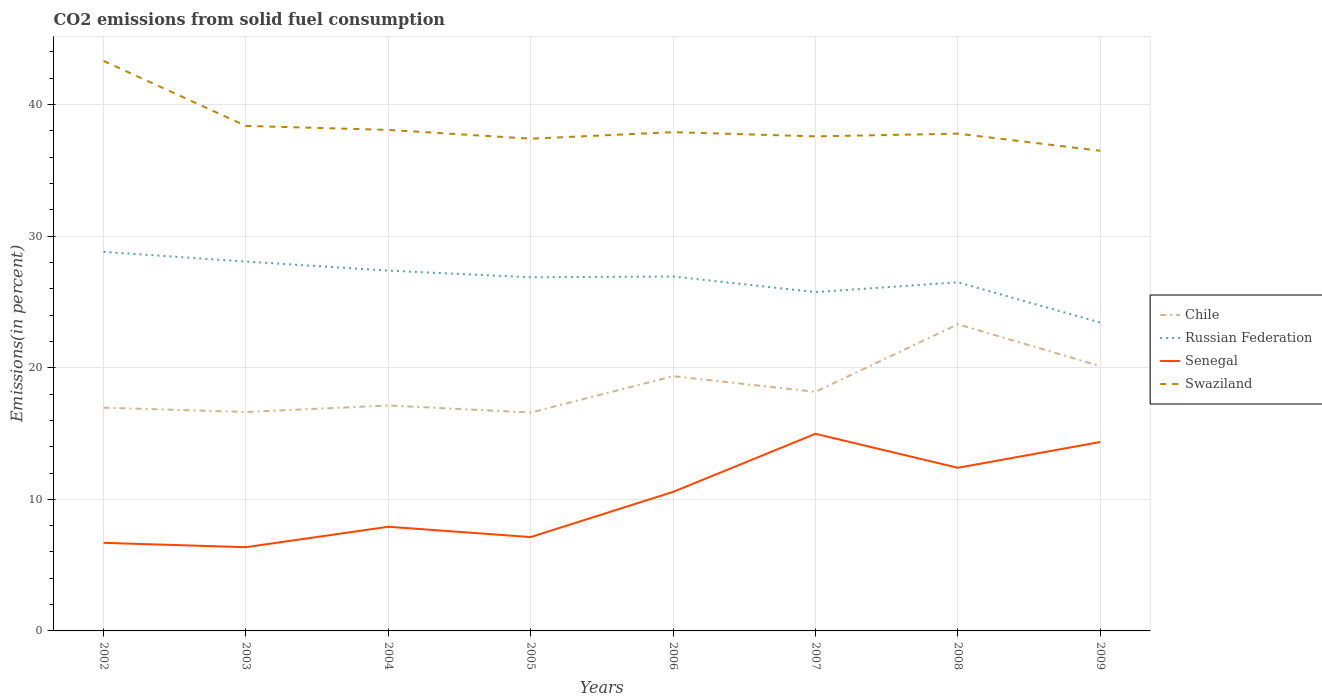How many different coloured lines are there?
Provide a succinct answer. 4. Is the number of lines equal to the number of legend labels?
Make the answer very short. Yes. Across all years, what is the maximum total CO2 emitted in Swaziland?
Offer a very short reply. 36.49. In which year was the total CO2 emitted in Chile maximum?
Your answer should be compact. 2005. What is the total total CO2 emitted in Swaziland in the graph?
Offer a terse response. 0.11. What is the difference between the highest and the second highest total CO2 emitted in Russian Federation?
Provide a succinct answer. 5.37. Is the total CO2 emitted in Chile strictly greater than the total CO2 emitted in Swaziland over the years?
Your response must be concise. Yes. How many lines are there?
Your response must be concise. 4. How many years are there in the graph?
Provide a succinct answer. 8. What is the difference between two consecutive major ticks on the Y-axis?
Your response must be concise. 10. Does the graph contain grids?
Offer a terse response. Yes. What is the title of the graph?
Provide a short and direct response. CO2 emissions from solid fuel consumption. Does "Russian Federation" appear as one of the legend labels in the graph?
Ensure brevity in your answer.  Yes. What is the label or title of the X-axis?
Offer a terse response. Years. What is the label or title of the Y-axis?
Give a very brief answer. Emissions(in percent). What is the Emissions(in percent) in Chile in 2002?
Provide a short and direct response. 16.96. What is the Emissions(in percent) of Russian Federation in 2002?
Offer a very short reply. 28.81. What is the Emissions(in percent) in Senegal in 2002?
Your response must be concise. 6.69. What is the Emissions(in percent) of Swaziland in 2002?
Make the answer very short. 43.32. What is the Emissions(in percent) of Chile in 2003?
Give a very brief answer. 16.64. What is the Emissions(in percent) in Russian Federation in 2003?
Offer a very short reply. 28.07. What is the Emissions(in percent) in Senegal in 2003?
Make the answer very short. 6.36. What is the Emissions(in percent) in Swaziland in 2003?
Give a very brief answer. 38.38. What is the Emissions(in percent) of Chile in 2004?
Your answer should be compact. 17.13. What is the Emissions(in percent) in Russian Federation in 2004?
Make the answer very short. 27.38. What is the Emissions(in percent) of Senegal in 2004?
Provide a short and direct response. 7.92. What is the Emissions(in percent) in Swaziland in 2004?
Offer a terse response. 38.08. What is the Emissions(in percent) of Chile in 2005?
Ensure brevity in your answer.  16.6. What is the Emissions(in percent) in Russian Federation in 2005?
Keep it short and to the point. 26.88. What is the Emissions(in percent) of Senegal in 2005?
Ensure brevity in your answer.  7.13. What is the Emissions(in percent) of Swaziland in 2005?
Make the answer very short. 37.41. What is the Emissions(in percent) of Chile in 2006?
Provide a short and direct response. 19.36. What is the Emissions(in percent) in Russian Federation in 2006?
Ensure brevity in your answer.  26.94. What is the Emissions(in percent) in Senegal in 2006?
Offer a terse response. 10.57. What is the Emissions(in percent) of Swaziland in 2006?
Your answer should be compact. 37.91. What is the Emissions(in percent) of Chile in 2007?
Your answer should be compact. 18.17. What is the Emissions(in percent) in Russian Federation in 2007?
Keep it short and to the point. 25.75. What is the Emissions(in percent) in Senegal in 2007?
Your answer should be compact. 14.98. What is the Emissions(in percent) in Swaziland in 2007?
Make the answer very short. 37.59. What is the Emissions(in percent) of Chile in 2008?
Make the answer very short. 23.31. What is the Emissions(in percent) in Russian Federation in 2008?
Ensure brevity in your answer.  26.5. What is the Emissions(in percent) of Senegal in 2008?
Your answer should be very brief. 12.4. What is the Emissions(in percent) in Swaziland in 2008?
Your answer should be compact. 37.79. What is the Emissions(in percent) of Chile in 2009?
Your answer should be compact. 20.12. What is the Emissions(in percent) in Russian Federation in 2009?
Offer a very short reply. 23.43. What is the Emissions(in percent) of Senegal in 2009?
Your response must be concise. 14.36. What is the Emissions(in percent) in Swaziland in 2009?
Provide a succinct answer. 36.49. Across all years, what is the maximum Emissions(in percent) of Chile?
Give a very brief answer. 23.31. Across all years, what is the maximum Emissions(in percent) in Russian Federation?
Offer a terse response. 28.81. Across all years, what is the maximum Emissions(in percent) of Senegal?
Your response must be concise. 14.98. Across all years, what is the maximum Emissions(in percent) in Swaziland?
Your answer should be compact. 43.32. Across all years, what is the minimum Emissions(in percent) of Chile?
Keep it short and to the point. 16.6. Across all years, what is the minimum Emissions(in percent) in Russian Federation?
Your answer should be very brief. 23.43. Across all years, what is the minimum Emissions(in percent) of Senegal?
Ensure brevity in your answer.  6.36. Across all years, what is the minimum Emissions(in percent) of Swaziland?
Offer a very short reply. 36.49. What is the total Emissions(in percent) in Chile in the graph?
Make the answer very short. 148.3. What is the total Emissions(in percent) in Russian Federation in the graph?
Offer a very short reply. 213.75. What is the total Emissions(in percent) of Senegal in the graph?
Your answer should be very brief. 80.41. What is the total Emissions(in percent) of Swaziland in the graph?
Your answer should be very brief. 306.97. What is the difference between the Emissions(in percent) of Chile in 2002 and that in 2003?
Your answer should be very brief. 0.33. What is the difference between the Emissions(in percent) in Russian Federation in 2002 and that in 2003?
Give a very brief answer. 0.74. What is the difference between the Emissions(in percent) in Senegal in 2002 and that in 2003?
Provide a succinct answer. 0.33. What is the difference between the Emissions(in percent) of Swaziland in 2002 and that in 2003?
Offer a terse response. 4.94. What is the difference between the Emissions(in percent) in Chile in 2002 and that in 2004?
Give a very brief answer. -0.17. What is the difference between the Emissions(in percent) in Russian Federation in 2002 and that in 2004?
Offer a very short reply. 1.43. What is the difference between the Emissions(in percent) of Senegal in 2002 and that in 2004?
Make the answer very short. -1.22. What is the difference between the Emissions(in percent) in Swaziland in 2002 and that in 2004?
Ensure brevity in your answer.  5.24. What is the difference between the Emissions(in percent) of Chile in 2002 and that in 2005?
Make the answer very short. 0.37. What is the difference between the Emissions(in percent) of Russian Federation in 2002 and that in 2005?
Offer a very short reply. 1.93. What is the difference between the Emissions(in percent) in Senegal in 2002 and that in 2005?
Your response must be concise. -0.44. What is the difference between the Emissions(in percent) of Swaziland in 2002 and that in 2005?
Your answer should be compact. 5.91. What is the difference between the Emissions(in percent) in Chile in 2002 and that in 2006?
Offer a very short reply. -2.4. What is the difference between the Emissions(in percent) in Russian Federation in 2002 and that in 2006?
Make the answer very short. 1.87. What is the difference between the Emissions(in percent) of Senegal in 2002 and that in 2006?
Offer a terse response. -3.87. What is the difference between the Emissions(in percent) in Swaziland in 2002 and that in 2006?
Ensure brevity in your answer.  5.42. What is the difference between the Emissions(in percent) of Chile in 2002 and that in 2007?
Your response must be concise. -1.21. What is the difference between the Emissions(in percent) of Russian Federation in 2002 and that in 2007?
Give a very brief answer. 3.06. What is the difference between the Emissions(in percent) in Senegal in 2002 and that in 2007?
Offer a very short reply. -8.29. What is the difference between the Emissions(in percent) of Swaziland in 2002 and that in 2007?
Provide a succinct answer. 5.74. What is the difference between the Emissions(in percent) of Chile in 2002 and that in 2008?
Offer a terse response. -6.34. What is the difference between the Emissions(in percent) in Russian Federation in 2002 and that in 2008?
Give a very brief answer. 2.31. What is the difference between the Emissions(in percent) of Senegal in 2002 and that in 2008?
Your answer should be very brief. -5.71. What is the difference between the Emissions(in percent) of Swaziland in 2002 and that in 2008?
Your answer should be compact. 5.53. What is the difference between the Emissions(in percent) in Chile in 2002 and that in 2009?
Give a very brief answer. -3.16. What is the difference between the Emissions(in percent) of Russian Federation in 2002 and that in 2009?
Offer a terse response. 5.38. What is the difference between the Emissions(in percent) of Senegal in 2002 and that in 2009?
Your answer should be compact. -7.66. What is the difference between the Emissions(in percent) in Swaziland in 2002 and that in 2009?
Provide a succinct answer. 6.83. What is the difference between the Emissions(in percent) in Chile in 2003 and that in 2004?
Your answer should be very brief. -0.49. What is the difference between the Emissions(in percent) in Russian Federation in 2003 and that in 2004?
Provide a succinct answer. 0.69. What is the difference between the Emissions(in percent) in Senegal in 2003 and that in 2004?
Provide a succinct answer. -1.55. What is the difference between the Emissions(in percent) in Swaziland in 2003 and that in 2004?
Your answer should be very brief. 0.3. What is the difference between the Emissions(in percent) of Chile in 2003 and that in 2005?
Offer a terse response. 0.04. What is the difference between the Emissions(in percent) of Russian Federation in 2003 and that in 2005?
Give a very brief answer. 1.19. What is the difference between the Emissions(in percent) of Senegal in 2003 and that in 2005?
Your response must be concise. -0.77. What is the difference between the Emissions(in percent) of Swaziland in 2003 and that in 2005?
Your answer should be very brief. 0.97. What is the difference between the Emissions(in percent) in Chile in 2003 and that in 2006?
Make the answer very short. -2.72. What is the difference between the Emissions(in percent) in Russian Federation in 2003 and that in 2006?
Your answer should be compact. 1.13. What is the difference between the Emissions(in percent) of Senegal in 2003 and that in 2006?
Ensure brevity in your answer.  -4.2. What is the difference between the Emissions(in percent) of Swaziland in 2003 and that in 2006?
Give a very brief answer. 0.47. What is the difference between the Emissions(in percent) in Chile in 2003 and that in 2007?
Provide a short and direct response. -1.53. What is the difference between the Emissions(in percent) in Russian Federation in 2003 and that in 2007?
Ensure brevity in your answer.  2.32. What is the difference between the Emissions(in percent) of Senegal in 2003 and that in 2007?
Your answer should be compact. -8.62. What is the difference between the Emissions(in percent) of Swaziland in 2003 and that in 2007?
Make the answer very short. 0.79. What is the difference between the Emissions(in percent) in Chile in 2003 and that in 2008?
Ensure brevity in your answer.  -6.67. What is the difference between the Emissions(in percent) of Russian Federation in 2003 and that in 2008?
Provide a succinct answer. 1.57. What is the difference between the Emissions(in percent) in Senegal in 2003 and that in 2008?
Keep it short and to the point. -6.03. What is the difference between the Emissions(in percent) in Swaziland in 2003 and that in 2008?
Your answer should be compact. 0.59. What is the difference between the Emissions(in percent) in Chile in 2003 and that in 2009?
Your response must be concise. -3.48. What is the difference between the Emissions(in percent) in Russian Federation in 2003 and that in 2009?
Offer a very short reply. 4.64. What is the difference between the Emissions(in percent) of Senegal in 2003 and that in 2009?
Your response must be concise. -7.99. What is the difference between the Emissions(in percent) of Swaziland in 2003 and that in 2009?
Keep it short and to the point. 1.89. What is the difference between the Emissions(in percent) in Chile in 2004 and that in 2005?
Make the answer very short. 0.54. What is the difference between the Emissions(in percent) of Russian Federation in 2004 and that in 2005?
Your answer should be very brief. 0.51. What is the difference between the Emissions(in percent) in Senegal in 2004 and that in 2005?
Provide a succinct answer. 0.78. What is the difference between the Emissions(in percent) in Swaziland in 2004 and that in 2005?
Your answer should be compact. 0.67. What is the difference between the Emissions(in percent) of Chile in 2004 and that in 2006?
Offer a terse response. -2.23. What is the difference between the Emissions(in percent) of Russian Federation in 2004 and that in 2006?
Your answer should be very brief. 0.45. What is the difference between the Emissions(in percent) in Senegal in 2004 and that in 2006?
Ensure brevity in your answer.  -2.65. What is the difference between the Emissions(in percent) of Swaziland in 2004 and that in 2006?
Your response must be concise. 0.17. What is the difference between the Emissions(in percent) of Chile in 2004 and that in 2007?
Offer a terse response. -1.04. What is the difference between the Emissions(in percent) in Russian Federation in 2004 and that in 2007?
Give a very brief answer. 1.63. What is the difference between the Emissions(in percent) of Senegal in 2004 and that in 2007?
Provide a succinct answer. -7.07. What is the difference between the Emissions(in percent) in Swaziland in 2004 and that in 2007?
Provide a short and direct response. 0.49. What is the difference between the Emissions(in percent) in Chile in 2004 and that in 2008?
Your answer should be very brief. -6.17. What is the difference between the Emissions(in percent) in Russian Federation in 2004 and that in 2008?
Your answer should be very brief. 0.89. What is the difference between the Emissions(in percent) in Senegal in 2004 and that in 2008?
Provide a succinct answer. -4.48. What is the difference between the Emissions(in percent) in Swaziland in 2004 and that in 2008?
Your answer should be very brief. 0.29. What is the difference between the Emissions(in percent) of Chile in 2004 and that in 2009?
Provide a short and direct response. -2.99. What is the difference between the Emissions(in percent) of Russian Federation in 2004 and that in 2009?
Ensure brevity in your answer.  3.95. What is the difference between the Emissions(in percent) of Senegal in 2004 and that in 2009?
Ensure brevity in your answer.  -6.44. What is the difference between the Emissions(in percent) in Swaziland in 2004 and that in 2009?
Keep it short and to the point. 1.59. What is the difference between the Emissions(in percent) in Chile in 2005 and that in 2006?
Make the answer very short. -2.76. What is the difference between the Emissions(in percent) in Russian Federation in 2005 and that in 2006?
Give a very brief answer. -0.06. What is the difference between the Emissions(in percent) of Senegal in 2005 and that in 2006?
Offer a very short reply. -3.43. What is the difference between the Emissions(in percent) of Swaziland in 2005 and that in 2006?
Your answer should be compact. -0.5. What is the difference between the Emissions(in percent) in Chile in 2005 and that in 2007?
Keep it short and to the point. -1.57. What is the difference between the Emissions(in percent) of Russian Federation in 2005 and that in 2007?
Offer a terse response. 1.12. What is the difference between the Emissions(in percent) of Senegal in 2005 and that in 2007?
Keep it short and to the point. -7.85. What is the difference between the Emissions(in percent) in Swaziland in 2005 and that in 2007?
Provide a succinct answer. -0.18. What is the difference between the Emissions(in percent) of Chile in 2005 and that in 2008?
Offer a very short reply. -6.71. What is the difference between the Emissions(in percent) of Russian Federation in 2005 and that in 2008?
Provide a succinct answer. 0.38. What is the difference between the Emissions(in percent) of Senegal in 2005 and that in 2008?
Keep it short and to the point. -5.26. What is the difference between the Emissions(in percent) of Swaziland in 2005 and that in 2008?
Provide a short and direct response. -0.38. What is the difference between the Emissions(in percent) in Chile in 2005 and that in 2009?
Your response must be concise. -3.53. What is the difference between the Emissions(in percent) of Russian Federation in 2005 and that in 2009?
Offer a very short reply. 3.44. What is the difference between the Emissions(in percent) in Senegal in 2005 and that in 2009?
Your answer should be very brief. -7.22. What is the difference between the Emissions(in percent) in Swaziland in 2005 and that in 2009?
Offer a very short reply. 0.92. What is the difference between the Emissions(in percent) of Chile in 2006 and that in 2007?
Your response must be concise. 1.19. What is the difference between the Emissions(in percent) in Russian Federation in 2006 and that in 2007?
Provide a succinct answer. 1.19. What is the difference between the Emissions(in percent) in Senegal in 2006 and that in 2007?
Provide a succinct answer. -4.42. What is the difference between the Emissions(in percent) in Swaziland in 2006 and that in 2007?
Ensure brevity in your answer.  0.32. What is the difference between the Emissions(in percent) of Chile in 2006 and that in 2008?
Your response must be concise. -3.95. What is the difference between the Emissions(in percent) of Russian Federation in 2006 and that in 2008?
Offer a terse response. 0.44. What is the difference between the Emissions(in percent) in Senegal in 2006 and that in 2008?
Your answer should be very brief. -1.83. What is the difference between the Emissions(in percent) in Swaziland in 2006 and that in 2008?
Ensure brevity in your answer.  0.11. What is the difference between the Emissions(in percent) in Chile in 2006 and that in 2009?
Make the answer very short. -0.76. What is the difference between the Emissions(in percent) of Russian Federation in 2006 and that in 2009?
Your answer should be very brief. 3.5. What is the difference between the Emissions(in percent) of Senegal in 2006 and that in 2009?
Provide a short and direct response. -3.79. What is the difference between the Emissions(in percent) of Swaziland in 2006 and that in 2009?
Ensure brevity in your answer.  1.41. What is the difference between the Emissions(in percent) in Chile in 2007 and that in 2008?
Offer a terse response. -5.14. What is the difference between the Emissions(in percent) of Russian Federation in 2007 and that in 2008?
Your answer should be very brief. -0.74. What is the difference between the Emissions(in percent) in Senegal in 2007 and that in 2008?
Make the answer very short. 2.58. What is the difference between the Emissions(in percent) in Swaziland in 2007 and that in 2008?
Your response must be concise. -0.21. What is the difference between the Emissions(in percent) in Chile in 2007 and that in 2009?
Your answer should be very brief. -1.95. What is the difference between the Emissions(in percent) in Russian Federation in 2007 and that in 2009?
Make the answer very short. 2.32. What is the difference between the Emissions(in percent) of Senegal in 2007 and that in 2009?
Your answer should be compact. 0.63. What is the difference between the Emissions(in percent) in Swaziland in 2007 and that in 2009?
Ensure brevity in your answer.  1.09. What is the difference between the Emissions(in percent) of Chile in 2008 and that in 2009?
Your answer should be compact. 3.19. What is the difference between the Emissions(in percent) of Russian Federation in 2008 and that in 2009?
Give a very brief answer. 3.06. What is the difference between the Emissions(in percent) of Senegal in 2008 and that in 2009?
Give a very brief answer. -1.96. What is the difference between the Emissions(in percent) in Swaziland in 2008 and that in 2009?
Keep it short and to the point. 1.3. What is the difference between the Emissions(in percent) in Chile in 2002 and the Emissions(in percent) in Russian Federation in 2003?
Make the answer very short. -11.11. What is the difference between the Emissions(in percent) in Chile in 2002 and the Emissions(in percent) in Senegal in 2003?
Provide a short and direct response. 10.6. What is the difference between the Emissions(in percent) of Chile in 2002 and the Emissions(in percent) of Swaziland in 2003?
Your answer should be very brief. -21.42. What is the difference between the Emissions(in percent) in Russian Federation in 2002 and the Emissions(in percent) in Senegal in 2003?
Offer a very short reply. 22.44. What is the difference between the Emissions(in percent) of Russian Federation in 2002 and the Emissions(in percent) of Swaziland in 2003?
Your response must be concise. -9.57. What is the difference between the Emissions(in percent) of Senegal in 2002 and the Emissions(in percent) of Swaziland in 2003?
Your response must be concise. -31.69. What is the difference between the Emissions(in percent) of Chile in 2002 and the Emissions(in percent) of Russian Federation in 2004?
Offer a terse response. -10.42. What is the difference between the Emissions(in percent) in Chile in 2002 and the Emissions(in percent) in Senegal in 2004?
Ensure brevity in your answer.  9.05. What is the difference between the Emissions(in percent) of Chile in 2002 and the Emissions(in percent) of Swaziland in 2004?
Offer a very short reply. -21.11. What is the difference between the Emissions(in percent) in Russian Federation in 2002 and the Emissions(in percent) in Senegal in 2004?
Offer a terse response. 20.89. What is the difference between the Emissions(in percent) of Russian Federation in 2002 and the Emissions(in percent) of Swaziland in 2004?
Your answer should be compact. -9.27. What is the difference between the Emissions(in percent) of Senegal in 2002 and the Emissions(in percent) of Swaziland in 2004?
Ensure brevity in your answer.  -31.38. What is the difference between the Emissions(in percent) of Chile in 2002 and the Emissions(in percent) of Russian Federation in 2005?
Your response must be concise. -9.91. What is the difference between the Emissions(in percent) in Chile in 2002 and the Emissions(in percent) in Senegal in 2005?
Make the answer very short. 9.83. What is the difference between the Emissions(in percent) in Chile in 2002 and the Emissions(in percent) in Swaziland in 2005?
Provide a succinct answer. -20.45. What is the difference between the Emissions(in percent) of Russian Federation in 2002 and the Emissions(in percent) of Senegal in 2005?
Ensure brevity in your answer.  21.67. What is the difference between the Emissions(in percent) of Russian Federation in 2002 and the Emissions(in percent) of Swaziland in 2005?
Your answer should be compact. -8.6. What is the difference between the Emissions(in percent) of Senegal in 2002 and the Emissions(in percent) of Swaziland in 2005?
Make the answer very short. -30.72. What is the difference between the Emissions(in percent) in Chile in 2002 and the Emissions(in percent) in Russian Federation in 2006?
Offer a very short reply. -9.97. What is the difference between the Emissions(in percent) of Chile in 2002 and the Emissions(in percent) of Senegal in 2006?
Your response must be concise. 6.4. What is the difference between the Emissions(in percent) in Chile in 2002 and the Emissions(in percent) in Swaziland in 2006?
Keep it short and to the point. -20.94. What is the difference between the Emissions(in percent) in Russian Federation in 2002 and the Emissions(in percent) in Senegal in 2006?
Provide a succinct answer. 18.24. What is the difference between the Emissions(in percent) of Russian Federation in 2002 and the Emissions(in percent) of Swaziland in 2006?
Provide a short and direct response. -9.1. What is the difference between the Emissions(in percent) of Senegal in 2002 and the Emissions(in percent) of Swaziland in 2006?
Make the answer very short. -31.21. What is the difference between the Emissions(in percent) in Chile in 2002 and the Emissions(in percent) in Russian Federation in 2007?
Make the answer very short. -8.79. What is the difference between the Emissions(in percent) in Chile in 2002 and the Emissions(in percent) in Senegal in 2007?
Give a very brief answer. 1.98. What is the difference between the Emissions(in percent) of Chile in 2002 and the Emissions(in percent) of Swaziland in 2007?
Make the answer very short. -20.62. What is the difference between the Emissions(in percent) of Russian Federation in 2002 and the Emissions(in percent) of Senegal in 2007?
Ensure brevity in your answer.  13.83. What is the difference between the Emissions(in percent) of Russian Federation in 2002 and the Emissions(in percent) of Swaziland in 2007?
Ensure brevity in your answer.  -8.78. What is the difference between the Emissions(in percent) in Senegal in 2002 and the Emissions(in percent) in Swaziland in 2007?
Your response must be concise. -30.89. What is the difference between the Emissions(in percent) in Chile in 2002 and the Emissions(in percent) in Russian Federation in 2008?
Give a very brief answer. -9.53. What is the difference between the Emissions(in percent) of Chile in 2002 and the Emissions(in percent) of Senegal in 2008?
Offer a very short reply. 4.57. What is the difference between the Emissions(in percent) in Chile in 2002 and the Emissions(in percent) in Swaziland in 2008?
Offer a very short reply. -20.83. What is the difference between the Emissions(in percent) in Russian Federation in 2002 and the Emissions(in percent) in Senegal in 2008?
Provide a succinct answer. 16.41. What is the difference between the Emissions(in percent) in Russian Federation in 2002 and the Emissions(in percent) in Swaziland in 2008?
Offer a terse response. -8.98. What is the difference between the Emissions(in percent) of Senegal in 2002 and the Emissions(in percent) of Swaziland in 2008?
Make the answer very short. -31.1. What is the difference between the Emissions(in percent) of Chile in 2002 and the Emissions(in percent) of Russian Federation in 2009?
Ensure brevity in your answer.  -6.47. What is the difference between the Emissions(in percent) of Chile in 2002 and the Emissions(in percent) of Senegal in 2009?
Offer a very short reply. 2.61. What is the difference between the Emissions(in percent) in Chile in 2002 and the Emissions(in percent) in Swaziland in 2009?
Your response must be concise. -19.53. What is the difference between the Emissions(in percent) of Russian Federation in 2002 and the Emissions(in percent) of Senegal in 2009?
Ensure brevity in your answer.  14.45. What is the difference between the Emissions(in percent) of Russian Federation in 2002 and the Emissions(in percent) of Swaziland in 2009?
Your response must be concise. -7.68. What is the difference between the Emissions(in percent) of Senegal in 2002 and the Emissions(in percent) of Swaziland in 2009?
Give a very brief answer. -29.8. What is the difference between the Emissions(in percent) of Chile in 2003 and the Emissions(in percent) of Russian Federation in 2004?
Your answer should be compact. -10.74. What is the difference between the Emissions(in percent) of Chile in 2003 and the Emissions(in percent) of Senegal in 2004?
Provide a succinct answer. 8.72. What is the difference between the Emissions(in percent) of Chile in 2003 and the Emissions(in percent) of Swaziland in 2004?
Offer a very short reply. -21.44. What is the difference between the Emissions(in percent) of Russian Federation in 2003 and the Emissions(in percent) of Senegal in 2004?
Your response must be concise. 20.15. What is the difference between the Emissions(in percent) of Russian Federation in 2003 and the Emissions(in percent) of Swaziland in 2004?
Your answer should be compact. -10.01. What is the difference between the Emissions(in percent) in Senegal in 2003 and the Emissions(in percent) in Swaziland in 2004?
Ensure brevity in your answer.  -31.71. What is the difference between the Emissions(in percent) of Chile in 2003 and the Emissions(in percent) of Russian Federation in 2005?
Your answer should be compact. -10.24. What is the difference between the Emissions(in percent) of Chile in 2003 and the Emissions(in percent) of Senegal in 2005?
Your response must be concise. 9.51. What is the difference between the Emissions(in percent) in Chile in 2003 and the Emissions(in percent) in Swaziland in 2005?
Your answer should be very brief. -20.77. What is the difference between the Emissions(in percent) of Russian Federation in 2003 and the Emissions(in percent) of Senegal in 2005?
Your answer should be compact. 20.94. What is the difference between the Emissions(in percent) in Russian Federation in 2003 and the Emissions(in percent) in Swaziland in 2005?
Offer a very short reply. -9.34. What is the difference between the Emissions(in percent) of Senegal in 2003 and the Emissions(in percent) of Swaziland in 2005?
Your answer should be very brief. -31.05. What is the difference between the Emissions(in percent) in Chile in 2003 and the Emissions(in percent) in Russian Federation in 2006?
Provide a succinct answer. -10.3. What is the difference between the Emissions(in percent) of Chile in 2003 and the Emissions(in percent) of Senegal in 2006?
Your answer should be very brief. 6.07. What is the difference between the Emissions(in percent) of Chile in 2003 and the Emissions(in percent) of Swaziland in 2006?
Make the answer very short. -21.27. What is the difference between the Emissions(in percent) in Russian Federation in 2003 and the Emissions(in percent) in Senegal in 2006?
Ensure brevity in your answer.  17.5. What is the difference between the Emissions(in percent) in Russian Federation in 2003 and the Emissions(in percent) in Swaziland in 2006?
Make the answer very short. -9.84. What is the difference between the Emissions(in percent) of Senegal in 2003 and the Emissions(in percent) of Swaziland in 2006?
Make the answer very short. -31.54. What is the difference between the Emissions(in percent) of Chile in 2003 and the Emissions(in percent) of Russian Federation in 2007?
Your response must be concise. -9.11. What is the difference between the Emissions(in percent) of Chile in 2003 and the Emissions(in percent) of Senegal in 2007?
Your answer should be compact. 1.66. What is the difference between the Emissions(in percent) of Chile in 2003 and the Emissions(in percent) of Swaziland in 2007?
Offer a very short reply. -20.95. What is the difference between the Emissions(in percent) in Russian Federation in 2003 and the Emissions(in percent) in Senegal in 2007?
Offer a very short reply. 13.09. What is the difference between the Emissions(in percent) of Russian Federation in 2003 and the Emissions(in percent) of Swaziland in 2007?
Make the answer very short. -9.52. What is the difference between the Emissions(in percent) in Senegal in 2003 and the Emissions(in percent) in Swaziland in 2007?
Your response must be concise. -31.22. What is the difference between the Emissions(in percent) of Chile in 2003 and the Emissions(in percent) of Russian Federation in 2008?
Provide a succinct answer. -9.86. What is the difference between the Emissions(in percent) of Chile in 2003 and the Emissions(in percent) of Senegal in 2008?
Give a very brief answer. 4.24. What is the difference between the Emissions(in percent) of Chile in 2003 and the Emissions(in percent) of Swaziland in 2008?
Your response must be concise. -21.15. What is the difference between the Emissions(in percent) in Russian Federation in 2003 and the Emissions(in percent) in Senegal in 2008?
Give a very brief answer. 15.67. What is the difference between the Emissions(in percent) in Russian Federation in 2003 and the Emissions(in percent) in Swaziland in 2008?
Your answer should be very brief. -9.72. What is the difference between the Emissions(in percent) in Senegal in 2003 and the Emissions(in percent) in Swaziland in 2008?
Provide a short and direct response. -31.43. What is the difference between the Emissions(in percent) of Chile in 2003 and the Emissions(in percent) of Russian Federation in 2009?
Your response must be concise. -6.79. What is the difference between the Emissions(in percent) of Chile in 2003 and the Emissions(in percent) of Senegal in 2009?
Your answer should be very brief. 2.28. What is the difference between the Emissions(in percent) in Chile in 2003 and the Emissions(in percent) in Swaziland in 2009?
Offer a terse response. -19.85. What is the difference between the Emissions(in percent) of Russian Federation in 2003 and the Emissions(in percent) of Senegal in 2009?
Offer a terse response. 13.71. What is the difference between the Emissions(in percent) of Russian Federation in 2003 and the Emissions(in percent) of Swaziland in 2009?
Your answer should be compact. -8.42. What is the difference between the Emissions(in percent) in Senegal in 2003 and the Emissions(in percent) in Swaziland in 2009?
Ensure brevity in your answer.  -30.13. What is the difference between the Emissions(in percent) in Chile in 2004 and the Emissions(in percent) in Russian Federation in 2005?
Provide a succinct answer. -9.74. What is the difference between the Emissions(in percent) in Chile in 2004 and the Emissions(in percent) in Senegal in 2005?
Offer a terse response. 10. What is the difference between the Emissions(in percent) of Chile in 2004 and the Emissions(in percent) of Swaziland in 2005?
Your answer should be very brief. -20.28. What is the difference between the Emissions(in percent) in Russian Federation in 2004 and the Emissions(in percent) in Senegal in 2005?
Your answer should be very brief. 20.25. What is the difference between the Emissions(in percent) in Russian Federation in 2004 and the Emissions(in percent) in Swaziland in 2005?
Keep it short and to the point. -10.03. What is the difference between the Emissions(in percent) in Senegal in 2004 and the Emissions(in percent) in Swaziland in 2005?
Keep it short and to the point. -29.49. What is the difference between the Emissions(in percent) in Chile in 2004 and the Emissions(in percent) in Russian Federation in 2006?
Your answer should be very brief. -9.8. What is the difference between the Emissions(in percent) in Chile in 2004 and the Emissions(in percent) in Senegal in 2006?
Offer a terse response. 6.57. What is the difference between the Emissions(in percent) of Chile in 2004 and the Emissions(in percent) of Swaziland in 2006?
Your answer should be very brief. -20.77. What is the difference between the Emissions(in percent) in Russian Federation in 2004 and the Emissions(in percent) in Senegal in 2006?
Give a very brief answer. 16.82. What is the difference between the Emissions(in percent) in Russian Federation in 2004 and the Emissions(in percent) in Swaziland in 2006?
Your answer should be very brief. -10.52. What is the difference between the Emissions(in percent) of Senegal in 2004 and the Emissions(in percent) of Swaziland in 2006?
Provide a succinct answer. -29.99. What is the difference between the Emissions(in percent) of Chile in 2004 and the Emissions(in percent) of Russian Federation in 2007?
Keep it short and to the point. -8.62. What is the difference between the Emissions(in percent) in Chile in 2004 and the Emissions(in percent) in Senegal in 2007?
Your answer should be very brief. 2.15. What is the difference between the Emissions(in percent) in Chile in 2004 and the Emissions(in percent) in Swaziland in 2007?
Your answer should be compact. -20.45. What is the difference between the Emissions(in percent) of Russian Federation in 2004 and the Emissions(in percent) of Senegal in 2007?
Provide a succinct answer. 12.4. What is the difference between the Emissions(in percent) in Russian Federation in 2004 and the Emissions(in percent) in Swaziland in 2007?
Ensure brevity in your answer.  -10.2. What is the difference between the Emissions(in percent) of Senegal in 2004 and the Emissions(in percent) of Swaziland in 2007?
Offer a terse response. -29.67. What is the difference between the Emissions(in percent) in Chile in 2004 and the Emissions(in percent) in Russian Federation in 2008?
Your answer should be very brief. -9.36. What is the difference between the Emissions(in percent) of Chile in 2004 and the Emissions(in percent) of Senegal in 2008?
Make the answer very short. 4.73. What is the difference between the Emissions(in percent) in Chile in 2004 and the Emissions(in percent) in Swaziland in 2008?
Give a very brief answer. -20.66. What is the difference between the Emissions(in percent) in Russian Federation in 2004 and the Emissions(in percent) in Senegal in 2008?
Offer a terse response. 14.98. What is the difference between the Emissions(in percent) of Russian Federation in 2004 and the Emissions(in percent) of Swaziland in 2008?
Give a very brief answer. -10.41. What is the difference between the Emissions(in percent) in Senegal in 2004 and the Emissions(in percent) in Swaziland in 2008?
Ensure brevity in your answer.  -29.88. What is the difference between the Emissions(in percent) of Chile in 2004 and the Emissions(in percent) of Russian Federation in 2009?
Ensure brevity in your answer.  -6.3. What is the difference between the Emissions(in percent) of Chile in 2004 and the Emissions(in percent) of Senegal in 2009?
Your answer should be compact. 2.78. What is the difference between the Emissions(in percent) of Chile in 2004 and the Emissions(in percent) of Swaziland in 2009?
Keep it short and to the point. -19.36. What is the difference between the Emissions(in percent) in Russian Federation in 2004 and the Emissions(in percent) in Senegal in 2009?
Ensure brevity in your answer.  13.03. What is the difference between the Emissions(in percent) in Russian Federation in 2004 and the Emissions(in percent) in Swaziland in 2009?
Give a very brief answer. -9.11. What is the difference between the Emissions(in percent) in Senegal in 2004 and the Emissions(in percent) in Swaziland in 2009?
Offer a terse response. -28.57. What is the difference between the Emissions(in percent) in Chile in 2005 and the Emissions(in percent) in Russian Federation in 2006?
Your answer should be very brief. -10.34. What is the difference between the Emissions(in percent) of Chile in 2005 and the Emissions(in percent) of Senegal in 2006?
Offer a very short reply. 6.03. What is the difference between the Emissions(in percent) in Chile in 2005 and the Emissions(in percent) in Swaziland in 2006?
Provide a succinct answer. -21.31. What is the difference between the Emissions(in percent) of Russian Federation in 2005 and the Emissions(in percent) of Senegal in 2006?
Give a very brief answer. 16.31. What is the difference between the Emissions(in percent) of Russian Federation in 2005 and the Emissions(in percent) of Swaziland in 2006?
Provide a succinct answer. -11.03. What is the difference between the Emissions(in percent) in Senegal in 2005 and the Emissions(in percent) in Swaziland in 2006?
Offer a very short reply. -30.77. What is the difference between the Emissions(in percent) of Chile in 2005 and the Emissions(in percent) of Russian Federation in 2007?
Offer a terse response. -9.15. What is the difference between the Emissions(in percent) of Chile in 2005 and the Emissions(in percent) of Senegal in 2007?
Offer a very short reply. 1.61. What is the difference between the Emissions(in percent) in Chile in 2005 and the Emissions(in percent) in Swaziland in 2007?
Your answer should be very brief. -20.99. What is the difference between the Emissions(in percent) of Russian Federation in 2005 and the Emissions(in percent) of Senegal in 2007?
Your answer should be compact. 11.89. What is the difference between the Emissions(in percent) of Russian Federation in 2005 and the Emissions(in percent) of Swaziland in 2007?
Offer a terse response. -10.71. What is the difference between the Emissions(in percent) of Senegal in 2005 and the Emissions(in percent) of Swaziland in 2007?
Provide a succinct answer. -30.45. What is the difference between the Emissions(in percent) in Chile in 2005 and the Emissions(in percent) in Russian Federation in 2008?
Your response must be concise. -9.9. What is the difference between the Emissions(in percent) of Chile in 2005 and the Emissions(in percent) of Senegal in 2008?
Offer a terse response. 4.2. What is the difference between the Emissions(in percent) of Chile in 2005 and the Emissions(in percent) of Swaziland in 2008?
Your answer should be very brief. -21.2. What is the difference between the Emissions(in percent) of Russian Federation in 2005 and the Emissions(in percent) of Senegal in 2008?
Offer a terse response. 14.48. What is the difference between the Emissions(in percent) in Russian Federation in 2005 and the Emissions(in percent) in Swaziland in 2008?
Your answer should be compact. -10.92. What is the difference between the Emissions(in percent) of Senegal in 2005 and the Emissions(in percent) of Swaziland in 2008?
Ensure brevity in your answer.  -30.66. What is the difference between the Emissions(in percent) in Chile in 2005 and the Emissions(in percent) in Russian Federation in 2009?
Offer a very short reply. -6.84. What is the difference between the Emissions(in percent) of Chile in 2005 and the Emissions(in percent) of Senegal in 2009?
Your response must be concise. 2.24. What is the difference between the Emissions(in percent) in Chile in 2005 and the Emissions(in percent) in Swaziland in 2009?
Keep it short and to the point. -19.89. What is the difference between the Emissions(in percent) of Russian Federation in 2005 and the Emissions(in percent) of Senegal in 2009?
Provide a short and direct response. 12.52. What is the difference between the Emissions(in percent) of Russian Federation in 2005 and the Emissions(in percent) of Swaziland in 2009?
Your response must be concise. -9.62. What is the difference between the Emissions(in percent) of Senegal in 2005 and the Emissions(in percent) of Swaziland in 2009?
Provide a succinct answer. -29.36. What is the difference between the Emissions(in percent) of Chile in 2006 and the Emissions(in percent) of Russian Federation in 2007?
Make the answer very short. -6.39. What is the difference between the Emissions(in percent) in Chile in 2006 and the Emissions(in percent) in Senegal in 2007?
Offer a terse response. 4.38. What is the difference between the Emissions(in percent) in Chile in 2006 and the Emissions(in percent) in Swaziland in 2007?
Offer a terse response. -18.23. What is the difference between the Emissions(in percent) of Russian Federation in 2006 and the Emissions(in percent) of Senegal in 2007?
Make the answer very short. 11.95. What is the difference between the Emissions(in percent) of Russian Federation in 2006 and the Emissions(in percent) of Swaziland in 2007?
Ensure brevity in your answer.  -10.65. What is the difference between the Emissions(in percent) of Senegal in 2006 and the Emissions(in percent) of Swaziland in 2007?
Your answer should be very brief. -27.02. What is the difference between the Emissions(in percent) in Chile in 2006 and the Emissions(in percent) in Russian Federation in 2008?
Provide a succinct answer. -7.14. What is the difference between the Emissions(in percent) in Chile in 2006 and the Emissions(in percent) in Senegal in 2008?
Your response must be concise. 6.96. What is the difference between the Emissions(in percent) of Chile in 2006 and the Emissions(in percent) of Swaziland in 2008?
Offer a terse response. -18.43. What is the difference between the Emissions(in percent) in Russian Federation in 2006 and the Emissions(in percent) in Senegal in 2008?
Provide a succinct answer. 14.54. What is the difference between the Emissions(in percent) in Russian Federation in 2006 and the Emissions(in percent) in Swaziland in 2008?
Give a very brief answer. -10.86. What is the difference between the Emissions(in percent) in Senegal in 2006 and the Emissions(in percent) in Swaziland in 2008?
Keep it short and to the point. -27.23. What is the difference between the Emissions(in percent) of Chile in 2006 and the Emissions(in percent) of Russian Federation in 2009?
Provide a short and direct response. -4.07. What is the difference between the Emissions(in percent) in Chile in 2006 and the Emissions(in percent) in Senegal in 2009?
Your response must be concise. 5. What is the difference between the Emissions(in percent) in Chile in 2006 and the Emissions(in percent) in Swaziland in 2009?
Offer a terse response. -17.13. What is the difference between the Emissions(in percent) in Russian Federation in 2006 and the Emissions(in percent) in Senegal in 2009?
Offer a terse response. 12.58. What is the difference between the Emissions(in percent) of Russian Federation in 2006 and the Emissions(in percent) of Swaziland in 2009?
Ensure brevity in your answer.  -9.55. What is the difference between the Emissions(in percent) of Senegal in 2006 and the Emissions(in percent) of Swaziland in 2009?
Give a very brief answer. -25.92. What is the difference between the Emissions(in percent) in Chile in 2007 and the Emissions(in percent) in Russian Federation in 2008?
Ensure brevity in your answer.  -8.32. What is the difference between the Emissions(in percent) in Chile in 2007 and the Emissions(in percent) in Senegal in 2008?
Keep it short and to the point. 5.77. What is the difference between the Emissions(in percent) in Chile in 2007 and the Emissions(in percent) in Swaziland in 2008?
Provide a short and direct response. -19.62. What is the difference between the Emissions(in percent) of Russian Federation in 2007 and the Emissions(in percent) of Senegal in 2008?
Your answer should be very brief. 13.35. What is the difference between the Emissions(in percent) in Russian Federation in 2007 and the Emissions(in percent) in Swaziland in 2008?
Offer a terse response. -12.04. What is the difference between the Emissions(in percent) of Senegal in 2007 and the Emissions(in percent) of Swaziland in 2008?
Provide a succinct answer. -22.81. What is the difference between the Emissions(in percent) in Chile in 2007 and the Emissions(in percent) in Russian Federation in 2009?
Your response must be concise. -5.26. What is the difference between the Emissions(in percent) of Chile in 2007 and the Emissions(in percent) of Senegal in 2009?
Keep it short and to the point. 3.81. What is the difference between the Emissions(in percent) in Chile in 2007 and the Emissions(in percent) in Swaziland in 2009?
Make the answer very short. -18.32. What is the difference between the Emissions(in percent) of Russian Federation in 2007 and the Emissions(in percent) of Senegal in 2009?
Offer a terse response. 11.39. What is the difference between the Emissions(in percent) in Russian Federation in 2007 and the Emissions(in percent) in Swaziland in 2009?
Give a very brief answer. -10.74. What is the difference between the Emissions(in percent) of Senegal in 2007 and the Emissions(in percent) of Swaziland in 2009?
Offer a terse response. -21.51. What is the difference between the Emissions(in percent) in Chile in 2008 and the Emissions(in percent) in Russian Federation in 2009?
Offer a very short reply. -0.13. What is the difference between the Emissions(in percent) in Chile in 2008 and the Emissions(in percent) in Senegal in 2009?
Ensure brevity in your answer.  8.95. What is the difference between the Emissions(in percent) of Chile in 2008 and the Emissions(in percent) of Swaziland in 2009?
Make the answer very short. -13.18. What is the difference between the Emissions(in percent) in Russian Federation in 2008 and the Emissions(in percent) in Senegal in 2009?
Your answer should be compact. 12.14. What is the difference between the Emissions(in percent) in Russian Federation in 2008 and the Emissions(in percent) in Swaziland in 2009?
Ensure brevity in your answer.  -10. What is the difference between the Emissions(in percent) of Senegal in 2008 and the Emissions(in percent) of Swaziland in 2009?
Provide a short and direct response. -24.09. What is the average Emissions(in percent) in Chile per year?
Provide a short and direct response. 18.54. What is the average Emissions(in percent) in Russian Federation per year?
Provide a succinct answer. 26.72. What is the average Emissions(in percent) of Senegal per year?
Your answer should be compact. 10.05. What is the average Emissions(in percent) of Swaziland per year?
Offer a terse response. 38.37. In the year 2002, what is the difference between the Emissions(in percent) in Chile and Emissions(in percent) in Russian Federation?
Offer a very short reply. -11.84. In the year 2002, what is the difference between the Emissions(in percent) in Chile and Emissions(in percent) in Senegal?
Offer a terse response. 10.27. In the year 2002, what is the difference between the Emissions(in percent) in Chile and Emissions(in percent) in Swaziland?
Provide a short and direct response. -26.36. In the year 2002, what is the difference between the Emissions(in percent) in Russian Federation and Emissions(in percent) in Senegal?
Keep it short and to the point. 22.11. In the year 2002, what is the difference between the Emissions(in percent) of Russian Federation and Emissions(in percent) of Swaziland?
Make the answer very short. -14.51. In the year 2002, what is the difference between the Emissions(in percent) of Senegal and Emissions(in percent) of Swaziland?
Your response must be concise. -36.63. In the year 2003, what is the difference between the Emissions(in percent) of Chile and Emissions(in percent) of Russian Federation?
Offer a very short reply. -11.43. In the year 2003, what is the difference between the Emissions(in percent) of Chile and Emissions(in percent) of Senegal?
Provide a short and direct response. 10.27. In the year 2003, what is the difference between the Emissions(in percent) of Chile and Emissions(in percent) of Swaziland?
Offer a very short reply. -21.74. In the year 2003, what is the difference between the Emissions(in percent) of Russian Federation and Emissions(in percent) of Senegal?
Make the answer very short. 21.71. In the year 2003, what is the difference between the Emissions(in percent) of Russian Federation and Emissions(in percent) of Swaziland?
Provide a succinct answer. -10.31. In the year 2003, what is the difference between the Emissions(in percent) in Senegal and Emissions(in percent) in Swaziland?
Your answer should be very brief. -32.02. In the year 2004, what is the difference between the Emissions(in percent) of Chile and Emissions(in percent) of Russian Federation?
Keep it short and to the point. -10.25. In the year 2004, what is the difference between the Emissions(in percent) of Chile and Emissions(in percent) of Senegal?
Provide a short and direct response. 9.22. In the year 2004, what is the difference between the Emissions(in percent) of Chile and Emissions(in percent) of Swaziland?
Provide a succinct answer. -20.94. In the year 2004, what is the difference between the Emissions(in percent) of Russian Federation and Emissions(in percent) of Senegal?
Your response must be concise. 19.47. In the year 2004, what is the difference between the Emissions(in percent) in Russian Federation and Emissions(in percent) in Swaziland?
Provide a short and direct response. -10.7. In the year 2004, what is the difference between the Emissions(in percent) of Senegal and Emissions(in percent) of Swaziland?
Offer a very short reply. -30.16. In the year 2005, what is the difference between the Emissions(in percent) in Chile and Emissions(in percent) in Russian Federation?
Your response must be concise. -10.28. In the year 2005, what is the difference between the Emissions(in percent) in Chile and Emissions(in percent) in Senegal?
Your response must be concise. 9.46. In the year 2005, what is the difference between the Emissions(in percent) in Chile and Emissions(in percent) in Swaziland?
Make the answer very short. -20.81. In the year 2005, what is the difference between the Emissions(in percent) in Russian Federation and Emissions(in percent) in Senegal?
Your response must be concise. 19.74. In the year 2005, what is the difference between the Emissions(in percent) of Russian Federation and Emissions(in percent) of Swaziland?
Offer a terse response. -10.53. In the year 2005, what is the difference between the Emissions(in percent) in Senegal and Emissions(in percent) in Swaziland?
Make the answer very short. -30.28. In the year 2006, what is the difference between the Emissions(in percent) of Chile and Emissions(in percent) of Russian Federation?
Provide a short and direct response. -7.58. In the year 2006, what is the difference between the Emissions(in percent) of Chile and Emissions(in percent) of Senegal?
Provide a short and direct response. 8.79. In the year 2006, what is the difference between the Emissions(in percent) in Chile and Emissions(in percent) in Swaziland?
Provide a succinct answer. -18.55. In the year 2006, what is the difference between the Emissions(in percent) of Russian Federation and Emissions(in percent) of Senegal?
Make the answer very short. 16.37. In the year 2006, what is the difference between the Emissions(in percent) of Russian Federation and Emissions(in percent) of Swaziland?
Your response must be concise. -10.97. In the year 2006, what is the difference between the Emissions(in percent) in Senegal and Emissions(in percent) in Swaziland?
Give a very brief answer. -27.34. In the year 2007, what is the difference between the Emissions(in percent) in Chile and Emissions(in percent) in Russian Federation?
Give a very brief answer. -7.58. In the year 2007, what is the difference between the Emissions(in percent) of Chile and Emissions(in percent) of Senegal?
Offer a terse response. 3.19. In the year 2007, what is the difference between the Emissions(in percent) of Chile and Emissions(in percent) of Swaziland?
Keep it short and to the point. -19.41. In the year 2007, what is the difference between the Emissions(in percent) in Russian Federation and Emissions(in percent) in Senegal?
Ensure brevity in your answer.  10.77. In the year 2007, what is the difference between the Emissions(in percent) in Russian Federation and Emissions(in percent) in Swaziland?
Ensure brevity in your answer.  -11.83. In the year 2007, what is the difference between the Emissions(in percent) of Senegal and Emissions(in percent) of Swaziland?
Your response must be concise. -22.6. In the year 2008, what is the difference between the Emissions(in percent) in Chile and Emissions(in percent) in Russian Federation?
Offer a very short reply. -3.19. In the year 2008, what is the difference between the Emissions(in percent) of Chile and Emissions(in percent) of Senegal?
Provide a short and direct response. 10.91. In the year 2008, what is the difference between the Emissions(in percent) of Chile and Emissions(in percent) of Swaziland?
Give a very brief answer. -14.48. In the year 2008, what is the difference between the Emissions(in percent) in Russian Federation and Emissions(in percent) in Senegal?
Offer a terse response. 14.1. In the year 2008, what is the difference between the Emissions(in percent) in Russian Federation and Emissions(in percent) in Swaziland?
Your answer should be compact. -11.3. In the year 2008, what is the difference between the Emissions(in percent) in Senegal and Emissions(in percent) in Swaziland?
Give a very brief answer. -25.39. In the year 2009, what is the difference between the Emissions(in percent) in Chile and Emissions(in percent) in Russian Federation?
Your answer should be very brief. -3.31. In the year 2009, what is the difference between the Emissions(in percent) in Chile and Emissions(in percent) in Senegal?
Provide a succinct answer. 5.77. In the year 2009, what is the difference between the Emissions(in percent) in Chile and Emissions(in percent) in Swaziland?
Your response must be concise. -16.37. In the year 2009, what is the difference between the Emissions(in percent) of Russian Federation and Emissions(in percent) of Senegal?
Your response must be concise. 9.08. In the year 2009, what is the difference between the Emissions(in percent) of Russian Federation and Emissions(in percent) of Swaziland?
Offer a very short reply. -13.06. In the year 2009, what is the difference between the Emissions(in percent) of Senegal and Emissions(in percent) of Swaziland?
Offer a terse response. -22.13. What is the ratio of the Emissions(in percent) of Chile in 2002 to that in 2003?
Provide a succinct answer. 1.02. What is the ratio of the Emissions(in percent) in Russian Federation in 2002 to that in 2003?
Keep it short and to the point. 1.03. What is the ratio of the Emissions(in percent) of Senegal in 2002 to that in 2003?
Keep it short and to the point. 1.05. What is the ratio of the Emissions(in percent) in Swaziland in 2002 to that in 2003?
Provide a succinct answer. 1.13. What is the ratio of the Emissions(in percent) in Chile in 2002 to that in 2004?
Keep it short and to the point. 0.99. What is the ratio of the Emissions(in percent) of Russian Federation in 2002 to that in 2004?
Offer a terse response. 1.05. What is the ratio of the Emissions(in percent) in Senegal in 2002 to that in 2004?
Keep it short and to the point. 0.85. What is the ratio of the Emissions(in percent) in Swaziland in 2002 to that in 2004?
Provide a short and direct response. 1.14. What is the ratio of the Emissions(in percent) in Chile in 2002 to that in 2005?
Your response must be concise. 1.02. What is the ratio of the Emissions(in percent) in Russian Federation in 2002 to that in 2005?
Keep it short and to the point. 1.07. What is the ratio of the Emissions(in percent) of Senegal in 2002 to that in 2005?
Ensure brevity in your answer.  0.94. What is the ratio of the Emissions(in percent) in Swaziland in 2002 to that in 2005?
Keep it short and to the point. 1.16. What is the ratio of the Emissions(in percent) of Chile in 2002 to that in 2006?
Provide a short and direct response. 0.88. What is the ratio of the Emissions(in percent) of Russian Federation in 2002 to that in 2006?
Provide a short and direct response. 1.07. What is the ratio of the Emissions(in percent) of Senegal in 2002 to that in 2006?
Give a very brief answer. 0.63. What is the ratio of the Emissions(in percent) of Chile in 2002 to that in 2007?
Your answer should be very brief. 0.93. What is the ratio of the Emissions(in percent) of Russian Federation in 2002 to that in 2007?
Provide a short and direct response. 1.12. What is the ratio of the Emissions(in percent) in Senegal in 2002 to that in 2007?
Your response must be concise. 0.45. What is the ratio of the Emissions(in percent) of Swaziland in 2002 to that in 2007?
Provide a short and direct response. 1.15. What is the ratio of the Emissions(in percent) in Chile in 2002 to that in 2008?
Your answer should be very brief. 0.73. What is the ratio of the Emissions(in percent) of Russian Federation in 2002 to that in 2008?
Offer a very short reply. 1.09. What is the ratio of the Emissions(in percent) in Senegal in 2002 to that in 2008?
Your response must be concise. 0.54. What is the ratio of the Emissions(in percent) in Swaziland in 2002 to that in 2008?
Provide a succinct answer. 1.15. What is the ratio of the Emissions(in percent) of Chile in 2002 to that in 2009?
Your response must be concise. 0.84. What is the ratio of the Emissions(in percent) of Russian Federation in 2002 to that in 2009?
Ensure brevity in your answer.  1.23. What is the ratio of the Emissions(in percent) of Senegal in 2002 to that in 2009?
Offer a very short reply. 0.47. What is the ratio of the Emissions(in percent) of Swaziland in 2002 to that in 2009?
Make the answer very short. 1.19. What is the ratio of the Emissions(in percent) of Chile in 2003 to that in 2004?
Your response must be concise. 0.97. What is the ratio of the Emissions(in percent) of Russian Federation in 2003 to that in 2004?
Your response must be concise. 1.03. What is the ratio of the Emissions(in percent) in Senegal in 2003 to that in 2004?
Give a very brief answer. 0.8. What is the ratio of the Emissions(in percent) in Swaziland in 2003 to that in 2004?
Offer a very short reply. 1.01. What is the ratio of the Emissions(in percent) in Russian Federation in 2003 to that in 2005?
Keep it short and to the point. 1.04. What is the ratio of the Emissions(in percent) in Senegal in 2003 to that in 2005?
Give a very brief answer. 0.89. What is the ratio of the Emissions(in percent) in Swaziland in 2003 to that in 2005?
Keep it short and to the point. 1.03. What is the ratio of the Emissions(in percent) in Chile in 2003 to that in 2006?
Offer a terse response. 0.86. What is the ratio of the Emissions(in percent) of Russian Federation in 2003 to that in 2006?
Offer a terse response. 1.04. What is the ratio of the Emissions(in percent) in Senegal in 2003 to that in 2006?
Offer a very short reply. 0.6. What is the ratio of the Emissions(in percent) of Swaziland in 2003 to that in 2006?
Ensure brevity in your answer.  1.01. What is the ratio of the Emissions(in percent) in Chile in 2003 to that in 2007?
Ensure brevity in your answer.  0.92. What is the ratio of the Emissions(in percent) of Russian Federation in 2003 to that in 2007?
Give a very brief answer. 1.09. What is the ratio of the Emissions(in percent) in Senegal in 2003 to that in 2007?
Offer a very short reply. 0.42. What is the ratio of the Emissions(in percent) in Swaziland in 2003 to that in 2007?
Your answer should be compact. 1.02. What is the ratio of the Emissions(in percent) in Chile in 2003 to that in 2008?
Give a very brief answer. 0.71. What is the ratio of the Emissions(in percent) in Russian Federation in 2003 to that in 2008?
Provide a succinct answer. 1.06. What is the ratio of the Emissions(in percent) in Senegal in 2003 to that in 2008?
Offer a terse response. 0.51. What is the ratio of the Emissions(in percent) of Swaziland in 2003 to that in 2008?
Make the answer very short. 1.02. What is the ratio of the Emissions(in percent) in Chile in 2003 to that in 2009?
Provide a succinct answer. 0.83. What is the ratio of the Emissions(in percent) in Russian Federation in 2003 to that in 2009?
Provide a short and direct response. 1.2. What is the ratio of the Emissions(in percent) of Senegal in 2003 to that in 2009?
Your response must be concise. 0.44. What is the ratio of the Emissions(in percent) of Swaziland in 2003 to that in 2009?
Ensure brevity in your answer.  1.05. What is the ratio of the Emissions(in percent) in Chile in 2004 to that in 2005?
Your response must be concise. 1.03. What is the ratio of the Emissions(in percent) in Russian Federation in 2004 to that in 2005?
Your answer should be compact. 1.02. What is the ratio of the Emissions(in percent) of Senegal in 2004 to that in 2005?
Give a very brief answer. 1.11. What is the ratio of the Emissions(in percent) of Swaziland in 2004 to that in 2005?
Keep it short and to the point. 1.02. What is the ratio of the Emissions(in percent) of Chile in 2004 to that in 2006?
Your response must be concise. 0.89. What is the ratio of the Emissions(in percent) of Russian Federation in 2004 to that in 2006?
Offer a terse response. 1.02. What is the ratio of the Emissions(in percent) in Senegal in 2004 to that in 2006?
Your answer should be very brief. 0.75. What is the ratio of the Emissions(in percent) in Chile in 2004 to that in 2007?
Provide a short and direct response. 0.94. What is the ratio of the Emissions(in percent) in Russian Federation in 2004 to that in 2007?
Your answer should be very brief. 1.06. What is the ratio of the Emissions(in percent) of Senegal in 2004 to that in 2007?
Offer a very short reply. 0.53. What is the ratio of the Emissions(in percent) of Swaziland in 2004 to that in 2007?
Your answer should be compact. 1.01. What is the ratio of the Emissions(in percent) of Chile in 2004 to that in 2008?
Provide a succinct answer. 0.74. What is the ratio of the Emissions(in percent) in Russian Federation in 2004 to that in 2008?
Your response must be concise. 1.03. What is the ratio of the Emissions(in percent) in Senegal in 2004 to that in 2008?
Provide a short and direct response. 0.64. What is the ratio of the Emissions(in percent) in Swaziland in 2004 to that in 2008?
Ensure brevity in your answer.  1.01. What is the ratio of the Emissions(in percent) in Chile in 2004 to that in 2009?
Make the answer very short. 0.85. What is the ratio of the Emissions(in percent) of Russian Federation in 2004 to that in 2009?
Your response must be concise. 1.17. What is the ratio of the Emissions(in percent) of Senegal in 2004 to that in 2009?
Keep it short and to the point. 0.55. What is the ratio of the Emissions(in percent) in Swaziland in 2004 to that in 2009?
Give a very brief answer. 1.04. What is the ratio of the Emissions(in percent) of Chile in 2005 to that in 2006?
Your answer should be very brief. 0.86. What is the ratio of the Emissions(in percent) in Senegal in 2005 to that in 2006?
Give a very brief answer. 0.68. What is the ratio of the Emissions(in percent) in Swaziland in 2005 to that in 2006?
Provide a succinct answer. 0.99. What is the ratio of the Emissions(in percent) of Chile in 2005 to that in 2007?
Make the answer very short. 0.91. What is the ratio of the Emissions(in percent) of Russian Federation in 2005 to that in 2007?
Make the answer very short. 1.04. What is the ratio of the Emissions(in percent) in Senegal in 2005 to that in 2007?
Your answer should be very brief. 0.48. What is the ratio of the Emissions(in percent) of Chile in 2005 to that in 2008?
Offer a very short reply. 0.71. What is the ratio of the Emissions(in percent) of Russian Federation in 2005 to that in 2008?
Keep it short and to the point. 1.01. What is the ratio of the Emissions(in percent) of Senegal in 2005 to that in 2008?
Ensure brevity in your answer.  0.58. What is the ratio of the Emissions(in percent) of Chile in 2005 to that in 2009?
Give a very brief answer. 0.82. What is the ratio of the Emissions(in percent) of Russian Federation in 2005 to that in 2009?
Provide a short and direct response. 1.15. What is the ratio of the Emissions(in percent) in Senegal in 2005 to that in 2009?
Provide a succinct answer. 0.5. What is the ratio of the Emissions(in percent) of Swaziland in 2005 to that in 2009?
Your response must be concise. 1.03. What is the ratio of the Emissions(in percent) in Chile in 2006 to that in 2007?
Make the answer very short. 1.07. What is the ratio of the Emissions(in percent) in Russian Federation in 2006 to that in 2007?
Give a very brief answer. 1.05. What is the ratio of the Emissions(in percent) of Senegal in 2006 to that in 2007?
Offer a very short reply. 0.71. What is the ratio of the Emissions(in percent) of Swaziland in 2006 to that in 2007?
Keep it short and to the point. 1.01. What is the ratio of the Emissions(in percent) in Chile in 2006 to that in 2008?
Your answer should be very brief. 0.83. What is the ratio of the Emissions(in percent) in Russian Federation in 2006 to that in 2008?
Offer a very short reply. 1.02. What is the ratio of the Emissions(in percent) in Senegal in 2006 to that in 2008?
Offer a terse response. 0.85. What is the ratio of the Emissions(in percent) of Swaziland in 2006 to that in 2008?
Offer a very short reply. 1. What is the ratio of the Emissions(in percent) of Chile in 2006 to that in 2009?
Offer a terse response. 0.96. What is the ratio of the Emissions(in percent) of Russian Federation in 2006 to that in 2009?
Offer a terse response. 1.15. What is the ratio of the Emissions(in percent) in Senegal in 2006 to that in 2009?
Offer a terse response. 0.74. What is the ratio of the Emissions(in percent) of Swaziland in 2006 to that in 2009?
Offer a very short reply. 1.04. What is the ratio of the Emissions(in percent) in Chile in 2007 to that in 2008?
Offer a terse response. 0.78. What is the ratio of the Emissions(in percent) in Russian Federation in 2007 to that in 2008?
Your answer should be compact. 0.97. What is the ratio of the Emissions(in percent) in Senegal in 2007 to that in 2008?
Offer a terse response. 1.21. What is the ratio of the Emissions(in percent) in Chile in 2007 to that in 2009?
Your answer should be compact. 0.9. What is the ratio of the Emissions(in percent) of Russian Federation in 2007 to that in 2009?
Provide a short and direct response. 1.1. What is the ratio of the Emissions(in percent) in Senegal in 2007 to that in 2009?
Keep it short and to the point. 1.04. What is the ratio of the Emissions(in percent) in Swaziland in 2007 to that in 2009?
Offer a very short reply. 1.03. What is the ratio of the Emissions(in percent) in Chile in 2008 to that in 2009?
Provide a succinct answer. 1.16. What is the ratio of the Emissions(in percent) in Russian Federation in 2008 to that in 2009?
Your response must be concise. 1.13. What is the ratio of the Emissions(in percent) in Senegal in 2008 to that in 2009?
Your response must be concise. 0.86. What is the ratio of the Emissions(in percent) of Swaziland in 2008 to that in 2009?
Your answer should be very brief. 1.04. What is the difference between the highest and the second highest Emissions(in percent) of Chile?
Provide a short and direct response. 3.19. What is the difference between the highest and the second highest Emissions(in percent) in Russian Federation?
Provide a short and direct response. 0.74. What is the difference between the highest and the second highest Emissions(in percent) of Senegal?
Offer a terse response. 0.63. What is the difference between the highest and the second highest Emissions(in percent) in Swaziland?
Keep it short and to the point. 4.94. What is the difference between the highest and the lowest Emissions(in percent) of Chile?
Give a very brief answer. 6.71. What is the difference between the highest and the lowest Emissions(in percent) of Russian Federation?
Provide a succinct answer. 5.38. What is the difference between the highest and the lowest Emissions(in percent) of Senegal?
Your answer should be compact. 8.62. What is the difference between the highest and the lowest Emissions(in percent) in Swaziland?
Give a very brief answer. 6.83. 